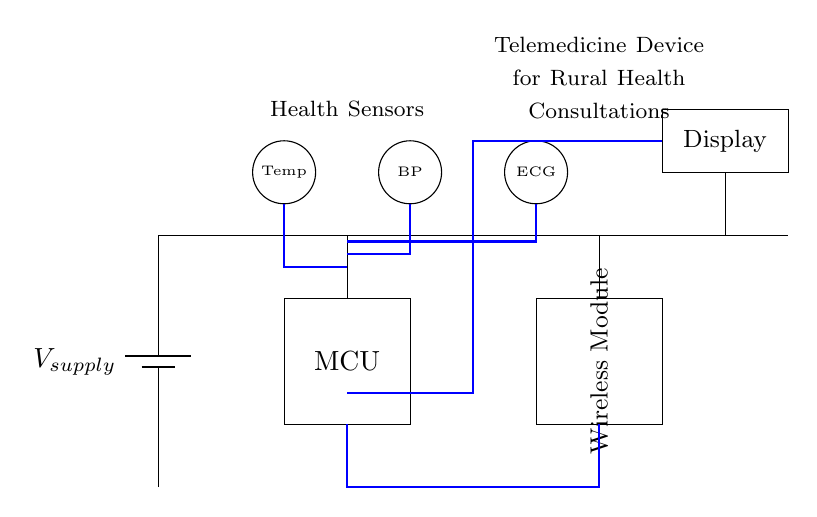What is the main power supply for this device? The circuit shows a battery labeled as V_supply, which indicates that it serves as the main power supply for the entire device.
Answer: V_supply How many sensors are included in the circuit? The circuit diagram displays three sensors: Temp, BP, and ECG, indicated by the circles representing the sensors at the top of the diagram.
Answer: Three What type of module is used for communication in this telemedicine device? The diagram includes a rectangular box labeled as Wireless Module, indicating that this device utilizes a wireless communication method.
Answer: Wireless Module What is the role of the microcontroller in this circuit? The microcontroller, indicated as MCU in the rectangle, serves as the central processing unit to control other components and process the data received from sensors.
Answer: Control unit What is the path of the data flow in the circuit? The data flow is represented by a blue thick line connecting the microcontroller to the sensors and the wireless module, suggesting that the data travels from the sensors to the MCU and then to the wireless module for transmission.
Answer: MCU to sensors to Wireless Module Which component displays the health data? The circuit shows a rectangle labeled Display which indicates that this component is responsible for showing the health data received from the sensors.
Answer: Display Explain how the sensors connect to the microcontroller. The circuit shows data lines connecting each sensor to the microcontroller (MCU). Each sensor outputs its data to the MCU, which consolidates and processes the information for transmission. The lines from Temp, BP, and ECG sensors are all routed to the MCU to ensure proper information relay and processing.
Answer: Sensors connect to MCU through data lines 